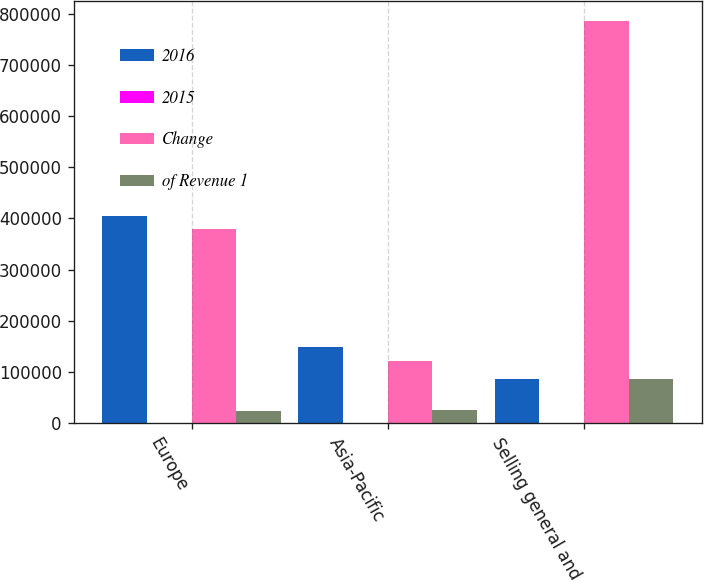Convert chart to OTSL. <chart><loc_0><loc_0><loc_500><loc_500><stacked_bar_chart><ecel><fcel>Europe<fcel>Asia-Pacific<fcel>Selling general and<nl><fcel>2016<fcel>403823<fcel>148457<fcel>85529<nl><fcel>2015<fcel>18.3<fcel>6.7<fcel>39.5<nl><fcel>Change<fcel>380246<fcel>121908<fcel>784823<nl><fcel>of Revenue 1<fcel>23577<fcel>26549<fcel>85529<nl></chart> 